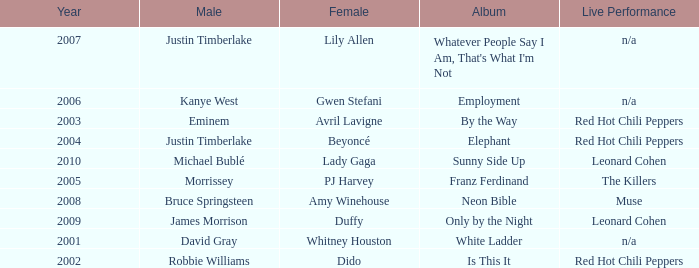Which female artist has an album named elephant? Beyoncé. 